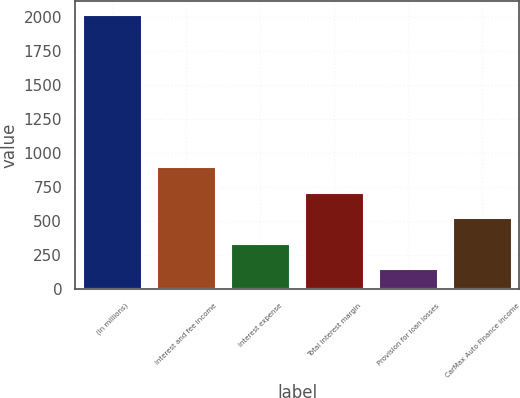<chart> <loc_0><loc_0><loc_500><loc_500><bar_chart><fcel>(In millions)<fcel>Interest and fee income<fcel>Interest expense<fcel>Total interest margin<fcel>Provision for loan losses<fcel>CarMax Auto Finance income<nl><fcel>2017<fcel>897.16<fcel>337.24<fcel>710.52<fcel>150.6<fcel>523.88<nl></chart> 